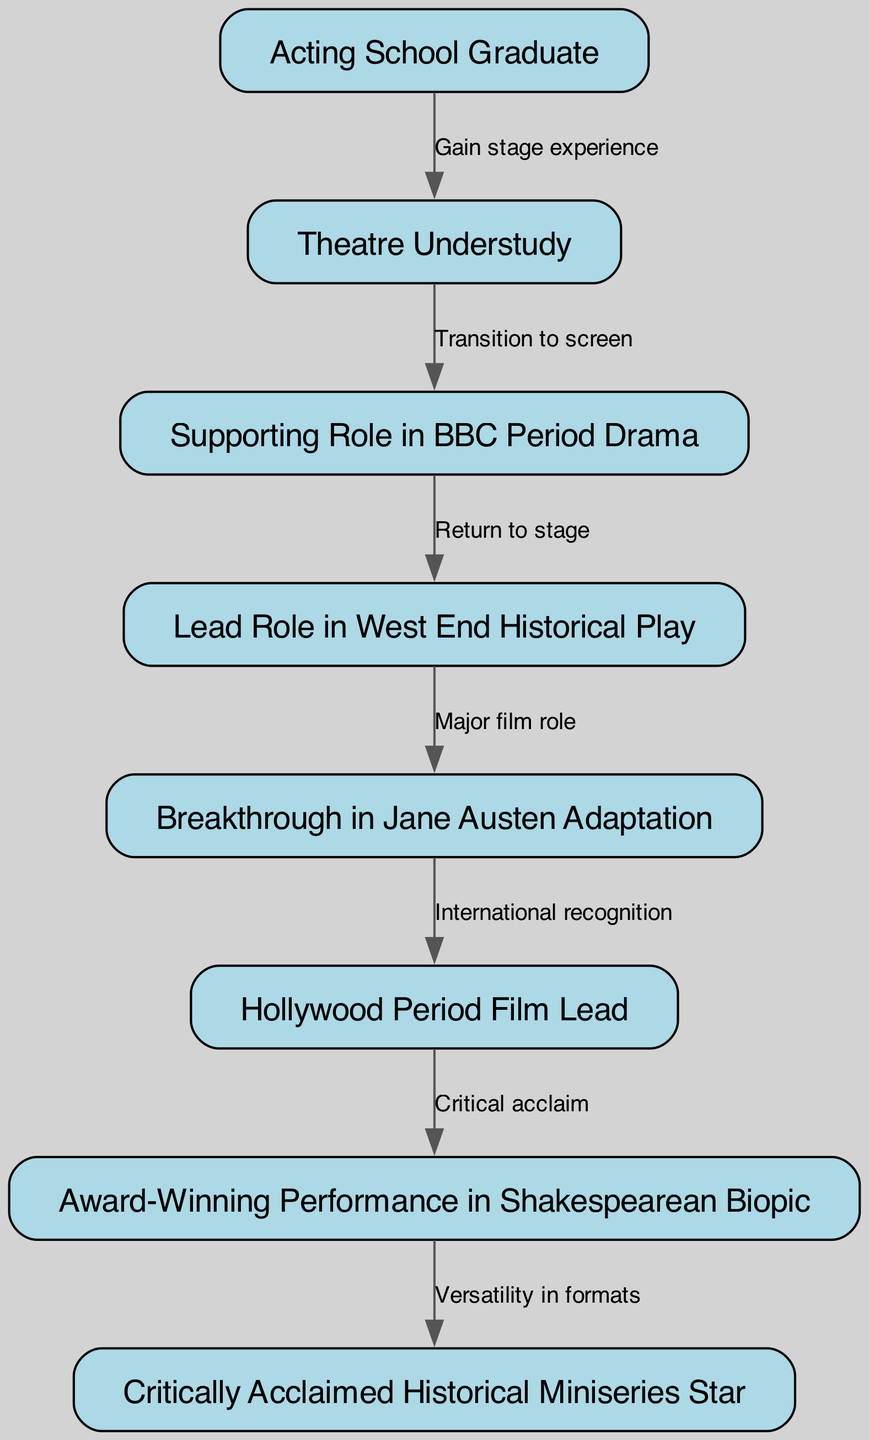What is the first step in the career progression? The first node in the diagram is "Acting School Graduate," representing the starting point of the career journey.
Answer: Acting School Graduate How many nodes are there in total? By counting the distinct career stages listed in the nodes section, we find there are eight nodes present in the diagram.
Answer: 8 What role is achieved after "Lead Role in West End Historical Play"? The edge stemming from "Lead Role in West End Historical Play" leads to "Breakthrough in Jane Austen Adaptation," indicating this role directly follows the West End performance.
Answer: Breakthrough in Jane Austen Adaptation Which role signifies "Critical acclaim"? The node "Award-Winning Performance in Shakespearean Biopic" is described as achieving critical acclaim, distinguishing it as a standout role in the actor's career.
Answer: Award-Winning Performance in Shakespearean Biopic What is the relationship between "Supporting Role in BBC Period Drama" and "Lead Role in West End Historical Play"? The edge connecting these two nodes indicates that the transition from the supporting role to a lead role in theatre is framed as a return to the stage after a screen transition.
Answer: Return to stage What is the last achievement in this career trajectory? The final node in the directed graph is "Critically Acclaimed Historical Miniseries Star," indicating this is the ultimate accomplishment in the depicted progression.
Answer: Critically Acclaimed Historical Miniseries Star What role follows after "Hollywood Period Film Lead"? The connection through the directed edge shows that "Hollywood Period Film Lead" leads to "Award-Winning Performance in Shakespearean Biopic," making it the next significant step in the career.
Answer: Award-Winning Performance in Shakespearean Biopic How does international recognition occur in this career path? The edge denotes that "Breakthrough in Jane Austen Adaptation" results in "Hollywood Period Film Lead," indicating that this breakthrough leads to international recognition for the actor's work.
Answer: International recognition 